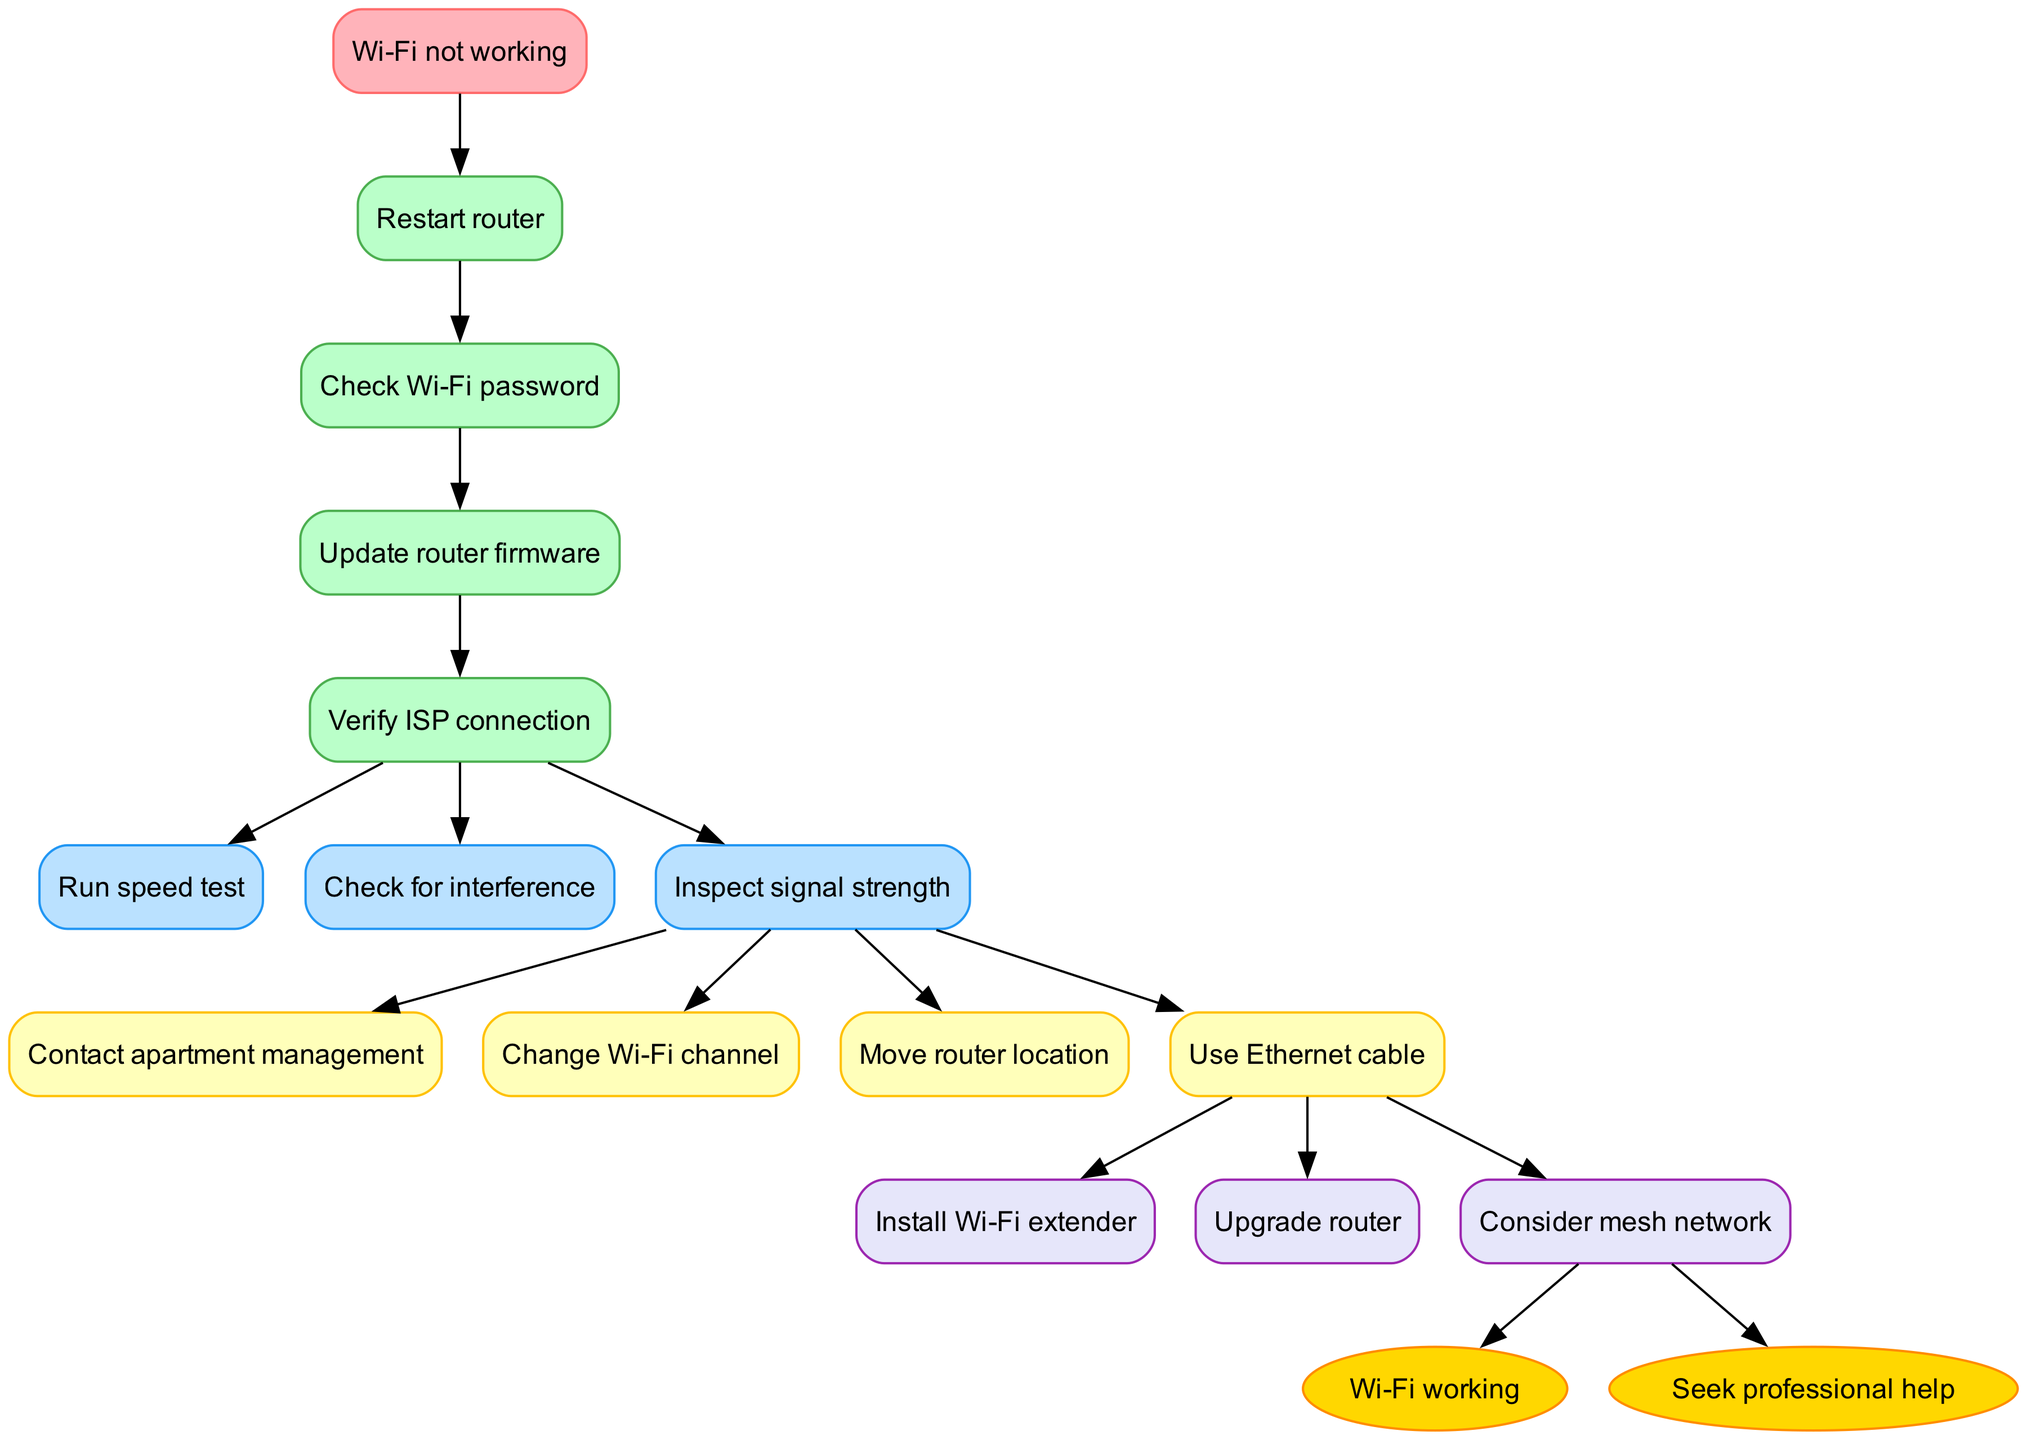What is the starting point of the flowchart? The diagram begins with the node labeled "Wi-Fi not working," indicating that this is where the troubleshooting process starts.
Answer: Wi-Fi not working How many checks are there in the flowchart? The diagram includes four checks listed before moving on to diagnostics, actions, and solutions, confirming the number of checks present.
Answer: 4 Which action follows the final diagnostic step? The flowchart shows that the final diagnostic leads to the actions section, specifically to the action labeled "Contact apartment management."
Answer: Contact apartment management What is the last solution listed in the diagram? Examining the solutions section, the last entry noted is "Consider mesh network," which indicates that it is the final suggested solution in the flowchart.
Answer: Consider mesh network What leads to the "Wi-Fi working" endpoint? The solution labeled "Install Wi-Fi extender" is shown to lead directly to the endpoint of "Wi-Fi working," indicating it is one of the resolutions to the original problem.
Answer: Install Wi-Fi extender If you have checked the Wi-Fi password, what comes next? After checking the Wi-Fi password, the next logical step according to the flowchart would be to update the router firmware, as indicated by the sequential arrangement of the nodes.
Answer: Update router firmware What kind of results can be expected from running a speed test? Following the troubleshooting path, if the diagnostic step of running a speed test is completed, the outcome is expected to help identify if the speed is an issue, tying the diagnostics closer to the potential actions and solutions.
Answer: Identifying speed issues What color represents the checks in the flowchart? The checks are represented in a light green color in the diagram, which indicates the steps that users should follow initially during the Wi-Fi troubleshooting process.
Answer: Light green How many endpoints are visible at the end of the flowchart? The flowchart concludes with two endpoints: "Wi-Fi working" and "Seek professional help," showing there are two possible outcomes to the troubleshooting process.
Answer: 2 